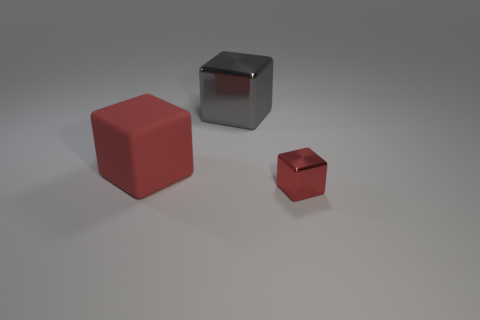Subtract all red cubes. How many cubes are left? 1 Subtract all yellow balls. How many red cubes are left? 2 Add 3 big objects. How many objects exist? 6 Subtract 1 cubes. How many cubes are left? 2 Subtract all red shiny cubes. Subtract all small red metallic blocks. How many objects are left? 1 Add 1 big metallic objects. How many big metallic objects are left? 2 Add 2 small red shiny objects. How many small red shiny objects exist? 3 Subtract 0 red balls. How many objects are left? 3 Subtract all green cubes. Subtract all gray cylinders. How many cubes are left? 3 